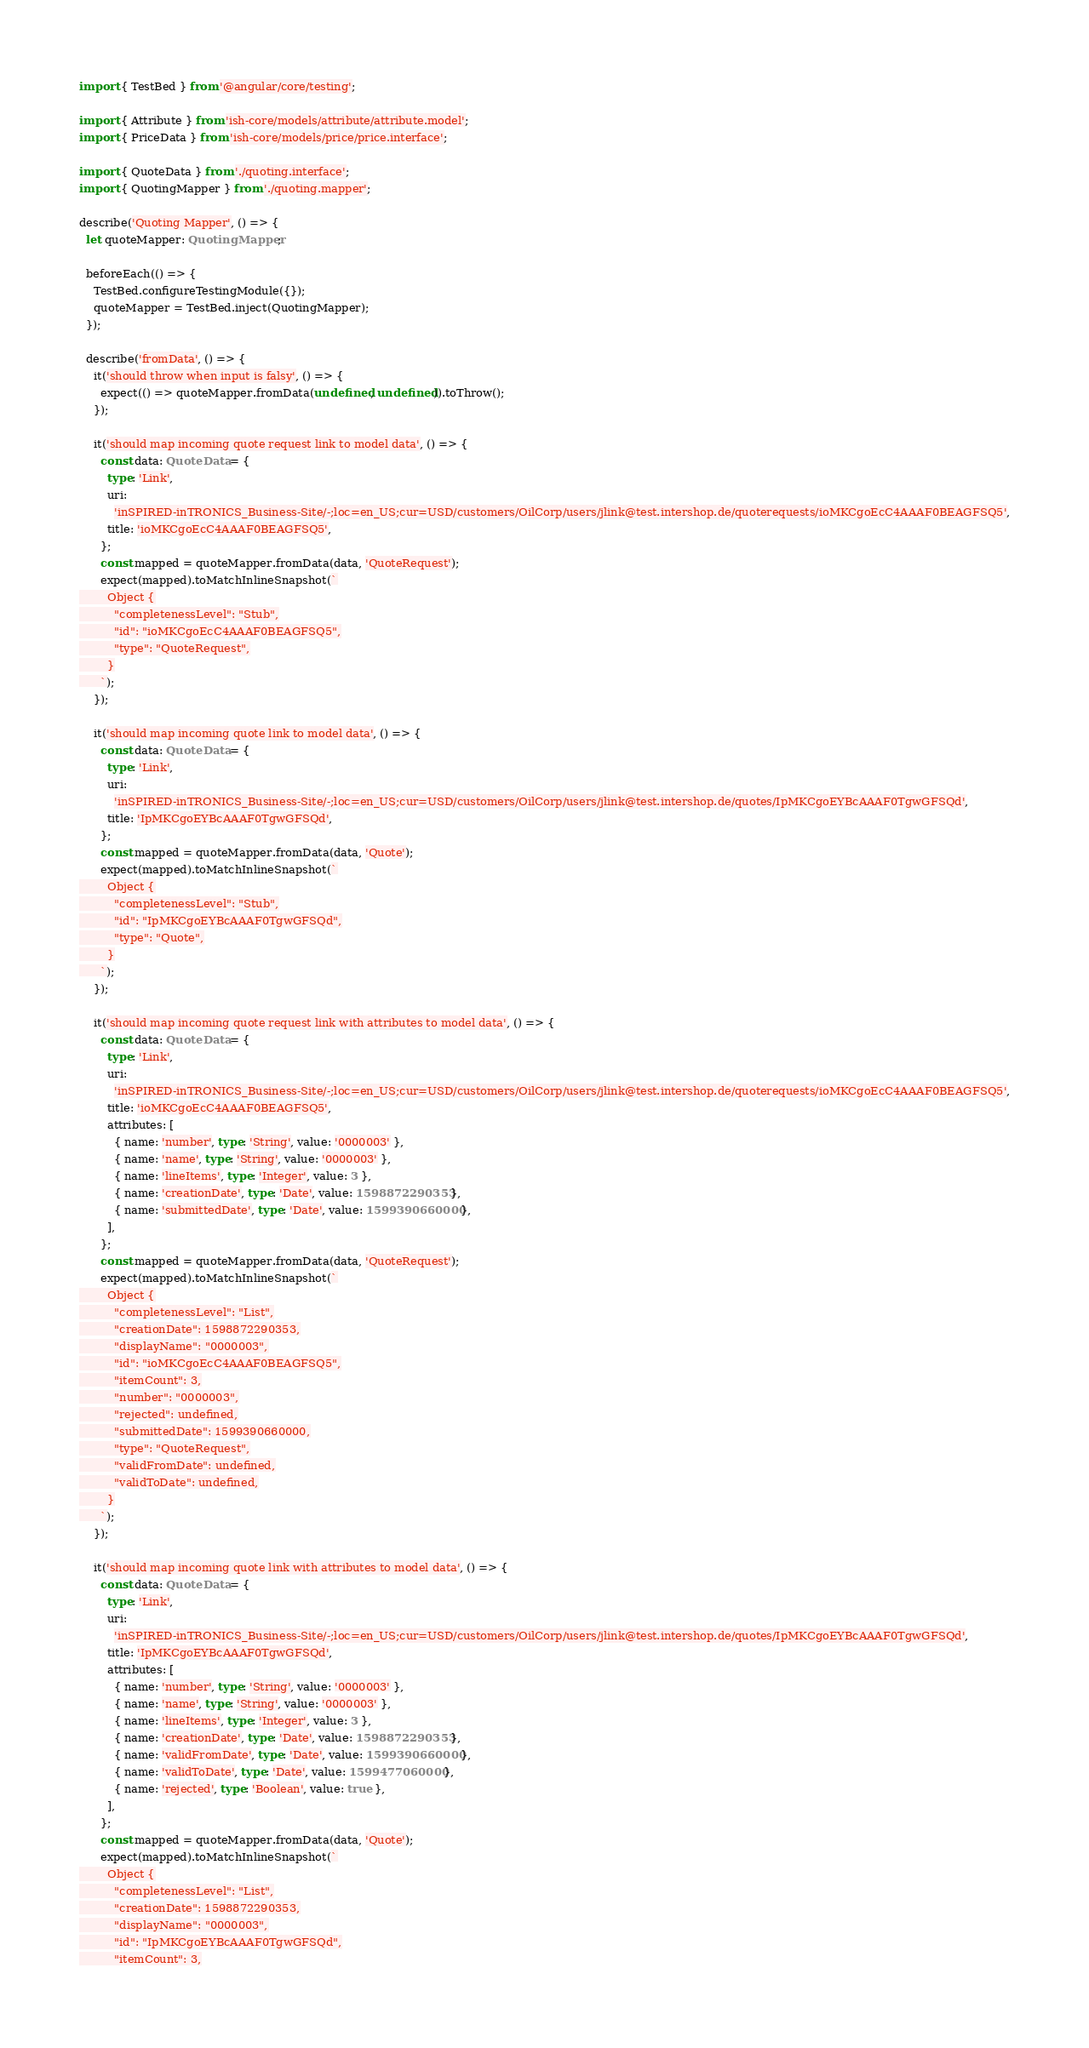<code> <loc_0><loc_0><loc_500><loc_500><_TypeScript_>import { TestBed } from '@angular/core/testing';

import { Attribute } from 'ish-core/models/attribute/attribute.model';
import { PriceData } from 'ish-core/models/price/price.interface';

import { QuoteData } from './quoting.interface';
import { QuotingMapper } from './quoting.mapper';

describe('Quoting Mapper', () => {
  let quoteMapper: QuotingMapper;

  beforeEach(() => {
    TestBed.configureTestingModule({});
    quoteMapper = TestBed.inject(QuotingMapper);
  });

  describe('fromData', () => {
    it('should throw when input is falsy', () => {
      expect(() => quoteMapper.fromData(undefined, undefined)).toThrow();
    });

    it('should map incoming quote request link to model data', () => {
      const data: QuoteData = {
        type: 'Link',
        uri:
          'inSPIRED-inTRONICS_Business-Site/-;loc=en_US;cur=USD/customers/OilCorp/users/jlink@test.intershop.de/quoterequests/ioMKCgoEcC4AAAF0BEAGFSQ5',
        title: 'ioMKCgoEcC4AAAF0BEAGFSQ5',
      };
      const mapped = quoteMapper.fromData(data, 'QuoteRequest');
      expect(mapped).toMatchInlineSnapshot(`
        Object {
          "completenessLevel": "Stub",
          "id": "ioMKCgoEcC4AAAF0BEAGFSQ5",
          "type": "QuoteRequest",
        }
      `);
    });

    it('should map incoming quote link to model data', () => {
      const data: QuoteData = {
        type: 'Link',
        uri:
          'inSPIRED-inTRONICS_Business-Site/-;loc=en_US;cur=USD/customers/OilCorp/users/jlink@test.intershop.de/quotes/IpMKCgoEYBcAAAF0TgwGFSQd',
        title: 'IpMKCgoEYBcAAAF0TgwGFSQd',
      };
      const mapped = quoteMapper.fromData(data, 'Quote');
      expect(mapped).toMatchInlineSnapshot(`
        Object {
          "completenessLevel": "Stub",
          "id": "IpMKCgoEYBcAAAF0TgwGFSQd",
          "type": "Quote",
        }
      `);
    });

    it('should map incoming quote request link with attributes to model data', () => {
      const data: QuoteData = {
        type: 'Link',
        uri:
          'inSPIRED-inTRONICS_Business-Site/-;loc=en_US;cur=USD/customers/OilCorp/users/jlink@test.intershop.de/quoterequests/ioMKCgoEcC4AAAF0BEAGFSQ5',
        title: 'ioMKCgoEcC4AAAF0BEAGFSQ5',
        attributes: [
          { name: 'number', type: 'String', value: '0000003' },
          { name: 'name', type: 'String', value: '0000003' },
          { name: 'lineItems', type: 'Integer', value: 3 },
          { name: 'creationDate', type: 'Date', value: 1598872290353 },
          { name: 'submittedDate', type: 'Date', value: 1599390660000 },
        ],
      };
      const mapped = quoteMapper.fromData(data, 'QuoteRequest');
      expect(mapped).toMatchInlineSnapshot(`
        Object {
          "completenessLevel": "List",
          "creationDate": 1598872290353,
          "displayName": "0000003",
          "id": "ioMKCgoEcC4AAAF0BEAGFSQ5",
          "itemCount": 3,
          "number": "0000003",
          "rejected": undefined,
          "submittedDate": 1599390660000,
          "type": "QuoteRequest",
          "validFromDate": undefined,
          "validToDate": undefined,
        }
      `);
    });

    it('should map incoming quote link with attributes to model data', () => {
      const data: QuoteData = {
        type: 'Link',
        uri:
          'inSPIRED-inTRONICS_Business-Site/-;loc=en_US;cur=USD/customers/OilCorp/users/jlink@test.intershop.de/quotes/IpMKCgoEYBcAAAF0TgwGFSQd',
        title: 'IpMKCgoEYBcAAAF0TgwGFSQd',
        attributes: [
          { name: 'number', type: 'String', value: '0000003' },
          { name: 'name', type: 'String', value: '0000003' },
          { name: 'lineItems', type: 'Integer', value: 3 },
          { name: 'creationDate', type: 'Date', value: 1598872290353 },
          { name: 'validFromDate', type: 'Date', value: 1599390660000 },
          { name: 'validToDate', type: 'Date', value: 1599477060000 },
          { name: 'rejected', type: 'Boolean', value: true },
        ],
      };
      const mapped = quoteMapper.fromData(data, 'Quote');
      expect(mapped).toMatchInlineSnapshot(`
        Object {
          "completenessLevel": "List",
          "creationDate": 1598872290353,
          "displayName": "0000003",
          "id": "IpMKCgoEYBcAAAF0TgwGFSQd",
          "itemCount": 3,</code> 